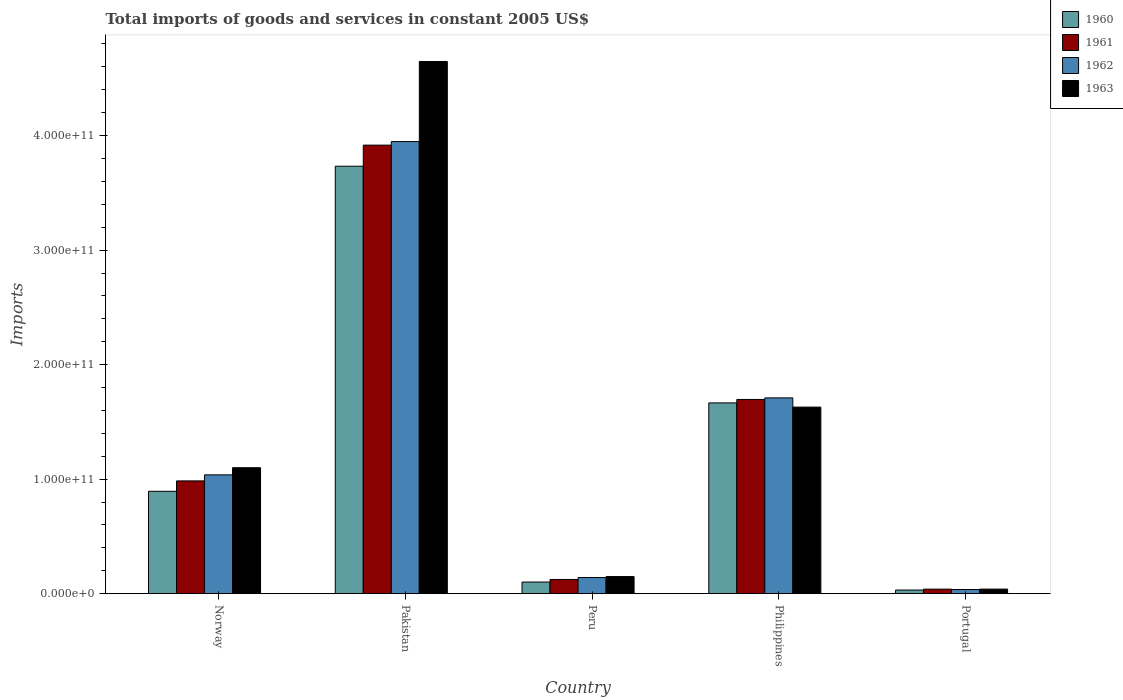Are the number of bars per tick equal to the number of legend labels?
Make the answer very short. Yes. How many bars are there on the 4th tick from the left?
Ensure brevity in your answer.  4. How many bars are there on the 3rd tick from the right?
Make the answer very short. 4. What is the label of the 2nd group of bars from the left?
Offer a terse response. Pakistan. In how many cases, is the number of bars for a given country not equal to the number of legend labels?
Ensure brevity in your answer.  0. What is the total imports of goods and services in 1960 in Norway?
Make the answer very short. 8.94e+1. Across all countries, what is the maximum total imports of goods and services in 1961?
Provide a succinct answer. 3.92e+11. Across all countries, what is the minimum total imports of goods and services in 1963?
Ensure brevity in your answer.  3.98e+09. In which country was the total imports of goods and services in 1963 maximum?
Your answer should be very brief. Pakistan. What is the total total imports of goods and services in 1963 in the graph?
Give a very brief answer. 7.57e+11. What is the difference between the total imports of goods and services in 1961 in Norway and that in Pakistan?
Your answer should be very brief. -2.93e+11. What is the difference between the total imports of goods and services in 1962 in Norway and the total imports of goods and services in 1960 in Portugal?
Offer a terse response. 1.01e+11. What is the average total imports of goods and services in 1963 per country?
Offer a terse response. 1.51e+11. What is the difference between the total imports of goods and services of/in 1961 and total imports of goods and services of/in 1963 in Philippines?
Your response must be concise. 6.69e+09. In how many countries, is the total imports of goods and services in 1963 greater than 300000000000 US$?
Offer a terse response. 1. What is the ratio of the total imports of goods and services in 1963 in Norway to that in Pakistan?
Your answer should be compact. 0.24. What is the difference between the highest and the second highest total imports of goods and services in 1963?
Ensure brevity in your answer.  -3.02e+11. What is the difference between the highest and the lowest total imports of goods and services in 1963?
Make the answer very short. 4.61e+11. Is it the case that in every country, the sum of the total imports of goods and services in 1960 and total imports of goods and services in 1963 is greater than the sum of total imports of goods and services in 1962 and total imports of goods and services in 1961?
Your answer should be compact. No. What does the 1st bar from the left in Portugal represents?
Your response must be concise. 1960. What does the 3rd bar from the right in Peru represents?
Your answer should be very brief. 1961. Are all the bars in the graph horizontal?
Your answer should be very brief. No. How many countries are there in the graph?
Your response must be concise. 5. What is the difference between two consecutive major ticks on the Y-axis?
Your answer should be very brief. 1.00e+11. Are the values on the major ticks of Y-axis written in scientific E-notation?
Make the answer very short. Yes. Does the graph contain any zero values?
Your response must be concise. No. Does the graph contain grids?
Make the answer very short. No. How are the legend labels stacked?
Keep it short and to the point. Vertical. What is the title of the graph?
Provide a succinct answer. Total imports of goods and services in constant 2005 US$. What is the label or title of the Y-axis?
Offer a very short reply. Imports. What is the Imports in 1960 in Norway?
Your answer should be compact. 8.94e+1. What is the Imports of 1961 in Norway?
Keep it short and to the point. 9.85e+1. What is the Imports in 1962 in Norway?
Make the answer very short. 1.04e+11. What is the Imports of 1963 in Norway?
Offer a terse response. 1.10e+11. What is the Imports in 1960 in Pakistan?
Ensure brevity in your answer.  3.73e+11. What is the Imports in 1961 in Pakistan?
Offer a very short reply. 3.92e+11. What is the Imports in 1962 in Pakistan?
Offer a terse response. 3.95e+11. What is the Imports in 1963 in Pakistan?
Give a very brief answer. 4.65e+11. What is the Imports in 1960 in Peru?
Your answer should be compact. 1.01e+1. What is the Imports of 1961 in Peru?
Your answer should be compact. 1.24e+1. What is the Imports of 1962 in Peru?
Provide a succinct answer. 1.41e+1. What is the Imports in 1963 in Peru?
Make the answer very short. 1.49e+1. What is the Imports in 1960 in Philippines?
Offer a terse response. 1.67e+11. What is the Imports in 1961 in Philippines?
Your answer should be compact. 1.70e+11. What is the Imports in 1962 in Philippines?
Offer a very short reply. 1.71e+11. What is the Imports in 1963 in Philippines?
Ensure brevity in your answer.  1.63e+11. What is the Imports in 1960 in Portugal?
Your answer should be very brief. 3.17e+09. What is the Imports of 1961 in Portugal?
Provide a succinct answer. 3.96e+09. What is the Imports of 1962 in Portugal?
Your answer should be compact. 3.62e+09. What is the Imports of 1963 in Portugal?
Give a very brief answer. 3.98e+09. Across all countries, what is the maximum Imports of 1960?
Offer a very short reply. 3.73e+11. Across all countries, what is the maximum Imports in 1961?
Your answer should be compact. 3.92e+11. Across all countries, what is the maximum Imports of 1962?
Give a very brief answer. 3.95e+11. Across all countries, what is the maximum Imports in 1963?
Ensure brevity in your answer.  4.65e+11. Across all countries, what is the minimum Imports of 1960?
Keep it short and to the point. 3.17e+09. Across all countries, what is the minimum Imports of 1961?
Your response must be concise. 3.96e+09. Across all countries, what is the minimum Imports of 1962?
Offer a very short reply. 3.62e+09. Across all countries, what is the minimum Imports in 1963?
Provide a short and direct response. 3.98e+09. What is the total Imports of 1960 in the graph?
Provide a succinct answer. 6.43e+11. What is the total Imports in 1961 in the graph?
Give a very brief answer. 6.76e+11. What is the total Imports of 1962 in the graph?
Your response must be concise. 6.87e+11. What is the total Imports of 1963 in the graph?
Provide a short and direct response. 7.57e+11. What is the difference between the Imports in 1960 in Norway and that in Pakistan?
Your response must be concise. -2.84e+11. What is the difference between the Imports of 1961 in Norway and that in Pakistan?
Give a very brief answer. -2.93e+11. What is the difference between the Imports in 1962 in Norway and that in Pakistan?
Keep it short and to the point. -2.91e+11. What is the difference between the Imports of 1963 in Norway and that in Pakistan?
Provide a succinct answer. -3.55e+11. What is the difference between the Imports of 1960 in Norway and that in Peru?
Your answer should be very brief. 7.92e+1. What is the difference between the Imports in 1961 in Norway and that in Peru?
Provide a succinct answer. 8.61e+1. What is the difference between the Imports in 1962 in Norway and that in Peru?
Keep it short and to the point. 8.97e+1. What is the difference between the Imports of 1963 in Norway and that in Peru?
Your response must be concise. 9.51e+1. What is the difference between the Imports of 1960 in Norway and that in Philippines?
Your answer should be compact. -7.72e+1. What is the difference between the Imports in 1961 in Norway and that in Philippines?
Offer a terse response. -7.11e+1. What is the difference between the Imports of 1962 in Norway and that in Philippines?
Offer a very short reply. -6.72e+1. What is the difference between the Imports in 1963 in Norway and that in Philippines?
Make the answer very short. -5.29e+1. What is the difference between the Imports in 1960 in Norway and that in Portugal?
Ensure brevity in your answer.  8.62e+1. What is the difference between the Imports in 1961 in Norway and that in Portugal?
Offer a very short reply. 9.45e+1. What is the difference between the Imports in 1962 in Norway and that in Portugal?
Offer a very short reply. 1.00e+11. What is the difference between the Imports in 1963 in Norway and that in Portugal?
Offer a very short reply. 1.06e+11. What is the difference between the Imports in 1960 in Pakistan and that in Peru?
Your answer should be very brief. 3.63e+11. What is the difference between the Imports of 1961 in Pakistan and that in Peru?
Offer a terse response. 3.79e+11. What is the difference between the Imports in 1962 in Pakistan and that in Peru?
Make the answer very short. 3.81e+11. What is the difference between the Imports in 1963 in Pakistan and that in Peru?
Give a very brief answer. 4.50e+11. What is the difference between the Imports of 1960 in Pakistan and that in Philippines?
Provide a short and direct response. 2.07e+11. What is the difference between the Imports of 1961 in Pakistan and that in Philippines?
Your response must be concise. 2.22e+11. What is the difference between the Imports in 1962 in Pakistan and that in Philippines?
Your answer should be very brief. 2.24e+11. What is the difference between the Imports in 1963 in Pakistan and that in Philippines?
Make the answer very short. 3.02e+11. What is the difference between the Imports of 1960 in Pakistan and that in Portugal?
Ensure brevity in your answer.  3.70e+11. What is the difference between the Imports in 1961 in Pakistan and that in Portugal?
Provide a short and direct response. 3.88e+11. What is the difference between the Imports of 1962 in Pakistan and that in Portugal?
Give a very brief answer. 3.91e+11. What is the difference between the Imports of 1963 in Pakistan and that in Portugal?
Your answer should be very brief. 4.61e+11. What is the difference between the Imports in 1960 in Peru and that in Philippines?
Make the answer very short. -1.56e+11. What is the difference between the Imports in 1961 in Peru and that in Philippines?
Keep it short and to the point. -1.57e+11. What is the difference between the Imports of 1962 in Peru and that in Philippines?
Give a very brief answer. -1.57e+11. What is the difference between the Imports in 1963 in Peru and that in Philippines?
Ensure brevity in your answer.  -1.48e+11. What is the difference between the Imports of 1960 in Peru and that in Portugal?
Your answer should be compact. 6.98e+09. What is the difference between the Imports in 1961 in Peru and that in Portugal?
Give a very brief answer. 8.43e+09. What is the difference between the Imports in 1962 in Peru and that in Portugal?
Your answer should be compact. 1.04e+1. What is the difference between the Imports of 1963 in Peru and that in Portugal?
Make the answer very short. 1.10e+1. What is the difference between the Imports in 1960 in Philippines and that in Portugal?
Keep it short and to the point. 1.63e+11. What is the difference between the Imports of 1961 in Philippines and that in Portugal?
Your answer should be compact. 1.66e+11. What is the difference between the Imports of 1962 in Philippines and that in Portugal?
Your response must be concise. 1.67e+11. What is the difference between the Imports in 1963 in Philippines and that in Portugal?
Ensure brevity in your answer.  1.59e+11. What is the difference between the Imports of 1960 in Norway and the Imports of 1961 in Pakistan?
Your answer should be very brief. -3.02e+11. What is the difference between the Imports in 1960 in Norway and the Imports in 1962 in Pakistan?
Offer a terse response. -3.05e+11. What is the difference between the Imports of 1960 in Norway and the Imports of 1963 in Pakistan?
Provide a short and direct response. -3.75e+11. What is the difference between the Imports of 1961 in Norway and the Imports of 1962 in Pakistan?
Provide a succinct answer. -2.96e+11. What is the difference between the Imports in 1961 in Norway and the Imports in 1963 in Pakistan?
Make the answer very short. -3.66e+11. What is the difference between the Imports of 1962 in Norway and the Imports of 1963 in Pakistan?
Give a very brief answer. -3.61e+11. What is the difference between the Imports in 1960 in Norway and the Imports in 1961 in Peru?
Offer a very short reply. 7.70e+1. What is the difference between the Imports in 1960 in Norway and the Imports in 1962 in Peru?
Your answer should be very brief. 7.53e+1. What is the difference between the Imports of 1960 in Norway and the Imports of 1963 in Peru?
Provide a succinct answer. 7.45e+1. What is the difference between the Imports of 1961 in Norway and the Imports of 1962 in Peru?
Ensure brevity in your answer.  8.44e+1. What is the difference between the Imports of 1961 in Norway and the Imports of 1963 in Peru?
Offer a very short reply. 8.35e+1. What is the difference between the Imports in 1962 in Norway and the Imports in 1963 in Peru?
Keep it short and to the point. 8.88e+1. What is the difference between the Imports of 1960 in Norway and the Imports of 1961 in Philippines?
Provide a succinct answer. -8.02e+1. What is the difference between the Imports of 1960 in Norway and the Imports of 1962 in Philippines?
Provide a succinct answer. -8.16e+1. What is the difference between the Imports of 1960 in Norway and the Imports of 1963 in Philippines?
Give a very brief answer. -7.35e+1. What is the difference between the Imports in 1961 in Norway and the Imports in 1962 in Philippines?
Offer a very short reply. -7.25e+1. What is the difference between the Imports in 1961 in Norway and the Imports in 1963 in Philippines?
Your answer should be compact. -6.44e+1. What is the difference between the Imports in 1962 in Norway and the Imports in 1963 in Philippines?
Provide a short and direct response. -5.92e+1. What is the difference between the Imports in 1960 in Norway and the Imports in 1961 in Portugal?
Provide a succinct answer. 8.54e+1. What is the difference between the Imports of 1960 in Norway and the Imports of 1962 in Portugal?
Offer a very short reply. 8.58e+1. What is the difference between the Imports in 1960 in Norway and the Imports in 1963 in Portugal?
Your response must be concise. 8.54e+1. What is the difference between the Imports of 1961 in Norway and the Imports of 1962 in Portugal?
Make the answer very short. 9.48e+1. What is the difference between the Imports in 1961 in Norway and the Imports in 1963 in Portugal?
Keep it short and to the point. 9.45e+1. What is the difference between the Imports of 1962 in Norway and the Imports of 1963 in Portugal?
Offer a very short reply. 9.98e+1. What is the difference between the Imports in 1960 in Pakistan and the Imports in 1961 in Peru?
Your answer should be compact. 3.61e+11. What is the difference between the Imports in 1960 in Pakistan and the Imports in 1962 in Peru?
Keep it short and to the point. 3.59e+11. What is the difference between the Imports in 1960 in Pakistan and the Imports in 1963 in Peru?
Give a very brief answer. 3.58e+11. What is the difference between the Imports of 1961 in Pakistan and the Imports of 1962 in Peru?
Provide a short and direct response. 3.78e+11. What is the difference between the Imports in 1961 in Pakistan and the Imports in 1963 in Peru?
Keep it short and to the point. 3.77e+11. What is the difference between the Imports in 1962 in Pakistan and the Imports in 1963 in Peru?
Provide a succinct answer. 3.80e+11. What is the difference between the Imports in 1960 in Pakistan and the Imports in 1961 in Philippines?
Offer a very short reply. 2.04e+11. What is the difference between the Imports in 1960 in Pakistan and the Imports in 1962 in Philippines?
Keep it short and to the point. 2.02e+11. What is the difference between the Imports in 1960 in Pakistan and the Imports in 1963 in Philippines?
Your response must be concise. 2.10e+11. What is the difference between the Imports of 1961 in Pakistan and the Imports of 1962 in Philippines?
Provide a short and direct response. 2.21e+11. What is the difference between the Imports in 1961 in Pakistan and the Imports in 1963 in Philippines?
Offer a terse response. 2.29e+11. What is the difference between the Imports in 1962 in Pakistan and the Imports in 1963 in Philippines?
Keep it short and to the point. 2.32e+11. What is the difference between the Imports in 1960 in Pakistan and the Imports in 1961 in Portugal?
Offer a terse response. 3.69e+11. What is the difference between the Imports in 1960 in Pakistan and the Imports in 1962 in Portugal?
Offer a very short reply. 3.70e+11. What is the difference between the Imports of 1960 in Pakistan and the Imports of 1963 in Portugal?
Offer a very short reply. 3.69e+11. What is the difference between the Imports of 1961 in Pakistan and the Imports of 1962 in Portugal?
Give a very brief answer. 3.88e+11. What is the difference between the Imports of 1961 in Pakistan and the Imports of 1963 in Portugal?
Offer a terse response. 3.88e+11. What is the difference between the Imports of 1962 in Pakistan and the Imports of 1963 in Portugal?
Offer a very short reply. 3.91e+11. What is the difference between the Imports of 1960 in Peru and the Imports of 1961 in Philippines?
Ensure brevity in your answer.  -1.59e+11. What is the difference between the Imports in 1960 in Peru and the Imports in 1962 in Philippines?
Make the answer very short. -1.61e+11. What is the difference between the Imports in 1960 in Peru and the Imports in 1963 in Philippines?
Provide a short and direct response. -1.53e+11. What is the difference between the Imports of 1961 in Peru and the Imports of 1962 in Philippines?
Offer a terse response. -1.59e+11. What is the difference between the Imports of 1961 in Peru and the Imports of 1963 in Philippines?
Offer a terse response. -1.51e+11. What is the difference between the Imports in 1962 in Peru and the Imports in 1963 in Philippines?
Your answer should be very brief. -1.49e+11. What is the difference between the Imports of 1960 in Peru and the Imports of 1961 in Portugal?
Keep it short and to the point. 6.19e+09. What is the difference between the Imports of 1960 in Peru and the Imports of 1962 in Portugal?
Offer a very short reply. 6.53e+09. What is the difference between the Imports in 1960 in Peru and the Imports in 1963 in Portugal?
Provide a succinct answer. 6.17e+09. What is the difference between the Imports in 1961 in Peru and the Imports in 1962 in Portugal?
Your answer should be compact. 8.77e+09. What is the difference between the Imports in 1961 in Peru and the Imports in 1963 in Portugal?
Offer a terse response. 8.41e+09. What is the difference between the Imports in 1962 in Peru and the Imports in 1963 in Portugal?
Make the answer very short. 1.01e+1. What is the difference between the Imports in 1960 in Philippines and the Imports in 1961 in Portugal?
Ensure brevity in your answer.  1.63e+11. What is the difference between the Imports in 1960 in Philippines and the Imports in 1962 in Portugal?
Give a very brief answer. 1.63e+11. What is the difference between the Imports in 1960 in Philippines and the Imports in 1963 in Portugal?
Your response must be concise. 1.63e+11. What is the difference between the Imports in 1961 in Philippines and the Imports in 1962 in Portugal?
Make the answer very short. 1.66e+11. What is the difference between the Imports of 1961 in Philippines and the Imports of 1963 in Portugal?
Your answer should be compact. 1.66e+11. What is the difference between the Imports in 1962 in Philippines and the Imports in 1963 in Portugal?
Your answer should be very brief. 1.67e+11. What is the average Imports in 1960 per country?
Provide a succinct answer. 1.29e+11. What is the average Imports of 1961 per country?
Provide a short and direct response. 1.35e+11. What is the average Imports of 1962 per country?
Make the answer very short. 1.37e+11. What is the average Imports of 1963 per country?
Keep it short and to the point. 1.51e+11. What is the difference between the Imports in 1960 and Imports in 1961 in Norway?
Keep it short and to the point. -9.07e+09. What is the difference between the Imports in 1960 and Imports in 1962 in Norway?
Offer a terse response. -1.44e+1. What is the difference between the Imports of 1960 and Imports of 1963 in Norway?
Provide a succinct answer. -2.06e+1. What is the difference between the Imports in 1961 and Imports in 1962 in Norway?
Provide a succinct answer. -5.28e+09. What is the difference between the Imports of 1961 and Imports of 1963 in Norway?
Your answer should be compact. -1.15e+1. What is the difference between the Imports of 1962 and Imports of 1963 in Norway?
Ensure brevity in your answer.  -6.24e+09. What is the difference between the Imports of 1960 and Imports of 1961 in Pakistan?
Give a very brief answer. -1.84e+1. What is the difference between the Imports in 1960 and Imports in 1962 in Pakistan?
Offer a very short reply. -2.15e+1. What is the difference between the Imports in 1960 and Imports in 1963 in Pakistan?
Ensure brevity in your answer.  -9.14e+1. What is the difference between the Imports in 1961 and Imports in 1962 in Pakistan?
Make the answer very short. -3.12e+09. What is the difference between the Imports in 1961 and Imports in 1963 in Pakistan?
Offer a very short reply. -7.30e+1. What is the difference between the Imports in 1962 and Imports in 1963 in Pakistan?
Ensure brevity in your answer.  -6.99e+1. What is the difference between the Imports in 1960 and Imports in 1961 in Peru?
Provide a succinct answer. -2.24e+09. What is the difference between the Imports of 1960 and Imports of 1962 in Peru?
Provide a short and direct response. -3.92e+09. What is the difference between the Imports in 1960 and Imports in 1963 in Peru?
Your answer should be very brief. -4.78e+09. What is the difference between the Imports in 1961 and Imports in 1962 in Peru?
Your answer should be very brief. -1.68e+09. What is the difference between the Imports in 1961 and Imports in 1963 in Peru?
Offer a terse response. -2.54e+09. What is the difference between the Imports of 1962 and Imports of 1963 in Peru?
Provide a short and direct response. -8.62e+08. What is the difference between the Imports in 1960 and Imports in 1961 in Philippines?
Your response must be concise. -3.01e+09. What is the difference between the Imports in 1960 and Imports in 1962 in Philippines?
Your answer should be compact. -4.37e+09. What is the difference between the Imports of 1960 and Imports of 1963 in Philippines?
Offer a terse response. 3.68e+09. What is the difference between the Imports in 1961 and Imports in 1962 in Philippines?
Provide a succinct answer. -1.36e+09. What is the difference between the Imports in 1961 and Imports in 1963 in Philippines?
Make the answer very short. 6.69e+09. What is the difference between the Imports in 1962 and Imports in 1963 in Philippines?
Your response must be concise. 8.04e+09. What is the difference between the Imports in 1960 and Imports in 1961 in Portugal?
Ensure brevity in your answer.  -7.89e+08. What is the difference between the Imports in 1960 and Imports in 1962 in Portugal?
Provide a succinct answer. -4.52e+08. What is the difference between the Imports in 1960 and Imports in 1963 in Portugal?
Give a very brief answer. -8.09e+08. What is the difference between the Imports in 1961 and Imports in 1962 in Portugal?
Offer a very short reply. 3.37e+08. What is the difference between the Imports of 1961 and Imports of 1963 in Portugal?
Ensure brevity in your answer.  -2.01e+07. What is the difference between the Imports in 1962 and Imports in 1963 in Portugal?
Keep it short and to the point. -3.57e+08. What is the ratio of the Imports in 1960 in Norway to that in Pakistan?
Your answer should be very brief. 0.24. What is the ratio of the Imports in 1961 in Norway to that in Pakistan?
Provide a succinct answer. 0.25. What is the ratio of the Imports in 1962 in Norway to that in Pakistan?
Make the answer very short. 0.26. What is the ratio of the Imports in 1963 in Norway to that in Pakistan?
Make the answer very short. 0.24. What is the ratio of the Imports in 1960 in Norway to that in Peru?
Your answer should be compact. 8.81. What is the ratio of the Imports in 1961 in Norway to that in Peru?
Ensure brevity in your answer.  7.95. What is the ratio of the Imports of 1962 in Norway to that in Peru?
Make the answer very short. 7.38. What is the ratio of the Imports of 1963 in Norway to that in Peru?
Provide a short and direct response. 7.37. What is the ratio of the Imports of 1960 in Norway to that in Philippines?
Ensure brevity in your answer.  0.54. What is the ratio of the Imports in 1961 in Norway to that in Philippines?
Your answer should be very brief. 0.58. What is the ratio of the Imports of 1962 in Norway to that in Philippines?
Make the answer very short. 0.61. What is the ratio of the Imports in 1963 in Norway to that in Philippines?
Give a very brief answer. 0.68. What is the ratio of the Imports of 1960 in Norway to that in Portugal?
Keep it short and to the point. 28.23. What is the ratio of the Imports of 1961 in Norway to that in Portugal?
Your answer should be compact. 24.89. What is the ratio of the Imports in 1962 in Norway to that in Portugal?
Keep it short and to the point. 28.66. What is the ratio of the Imports of 1963 in Norway to that in Portugal?
Provide a short and direct response. 27.66. What is the ratio of the Imports of 1960 in Pakistan to that in Peru?
Provide a succinct answer. 36.79. What is the ratio of the Imports in 1961 in Pakistan to that in Peru?
Provide a short and direct response. 31.62. What is the ratio of the Imports in 1962 in Pakistan to that in Peru?
Keep it short and to the point. 28.07. What is the ratio of the Imports in 1963 in Pakistan to that in Peru?
Keep it short and to the point. 31.13. What is the ratio of the Imports in 1960 in Pakistan to that in Philippines?
Provide a short and direct response. 2.24. What is the ratio of the Imports of 1961 in Pakistan to that in Philippines?
Your answer should be compact. 2.31. What is the ratio of the Imports of 1962 in Pakistan to that in Philippines?
Your answer should be compact. 2.31. What is the ratio of the Imports in 1963 in Pakistan to that in Philippines?
Your answer should be compact. 2.85. What is the ratio of the Imports of 1960 in Pakistan to that in Portugal?
Keep it short and to the point. 117.86. What is the ratio of the Imports of 1961 in Pakistan to that in Portugal?
Your answer should be very brief. 99. What is the ratio of the Imports of 1962 in Pakistan to that in Portugal?
Your response must be concise. 109.08. What is the ratio of the Imports in 1963 in Pakistan to that in Portugal?
Your response must be concise. 116.87. What is the ratio of the Imports in 1960 in Peru to that in Philippines?
Your answer should be compact. 0.06. What is the ratio of the Imports in 1961 in Peru to that in Philippines?
Provide a short and direct response. 0.07. What is the ratio of the Imports of 1962 in Peru to that in Philippines?
Make the answer very short. 0.08. What is the ratio of the Imports in 1963 in Peru to that in Philippines?
Offer a very short reply. 0.09. What is the ratio of the Imports in 1960 in Peru to that in Portugal?
Make the answer very short. 3.2. What is the ratio of the Imports of 1961 in Peru to that in Portugal?
Offer a terse response. 3.13. What is the ratio of the Imports of 1962 in Peru to that in Portugal?
Offer a terse response. 3.89. What is the ratio of the Imports of 1963 in Peru to that in Portugal?
Offer a terse response. 3.75. What is the ratio of the Imports of 1960 in Philippines to that in Portugal?
Provide a short and direct response. 52.6. What is the ratio of the Imports of 1961 in Philippines to that in Portugal?
Provide a succinct answer. 42.87. What is the ratio of the Imports in 1962 in Philippines to that in Portugal?
Ensure brevity in your answer.  47.23. What is the ratio of the Imports of 1963 in Philippines to that in Portugal?
Provide a succinct answer. 40.97. What is the difference between the highest and the second highest Imports of 1960?
Provide a succinct answer. 2.07e+11. What is the difference between the highest and the second highest Imports in 1961?
Provide a short and direct response. 2.22e+11. What is the difference between the highest and the second highest Imports of 1962?
Offer a terse response. 2.24e+11. What is the difference between the highest and the second highest Imports in 1963?
Your answer should be very brief. 3.02e+11. What is the difference between the highest and the lowest Imports of 1960?
Your response must be concise. 3.70e+11. What is the difference between the highest and the lowest Imports in 1961?
Keep it short and to the point. 3.88e+11. What is the difference between the highest and the lowest Imports of 1962?
Offer a terse response. 3.91e+11. What is the difference between the highest and the lowest Imports in 1963?
Give a very brief answer. 4.61e+11. 